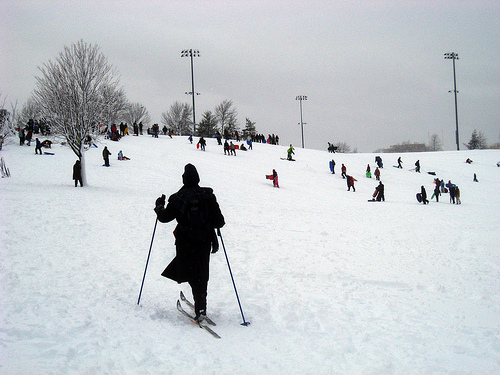Please provide a short description for this region: [0.64, 0.61, 0.87, 0.77]. A patch of pristine, white snow that contrasts with the dark elements around it. 